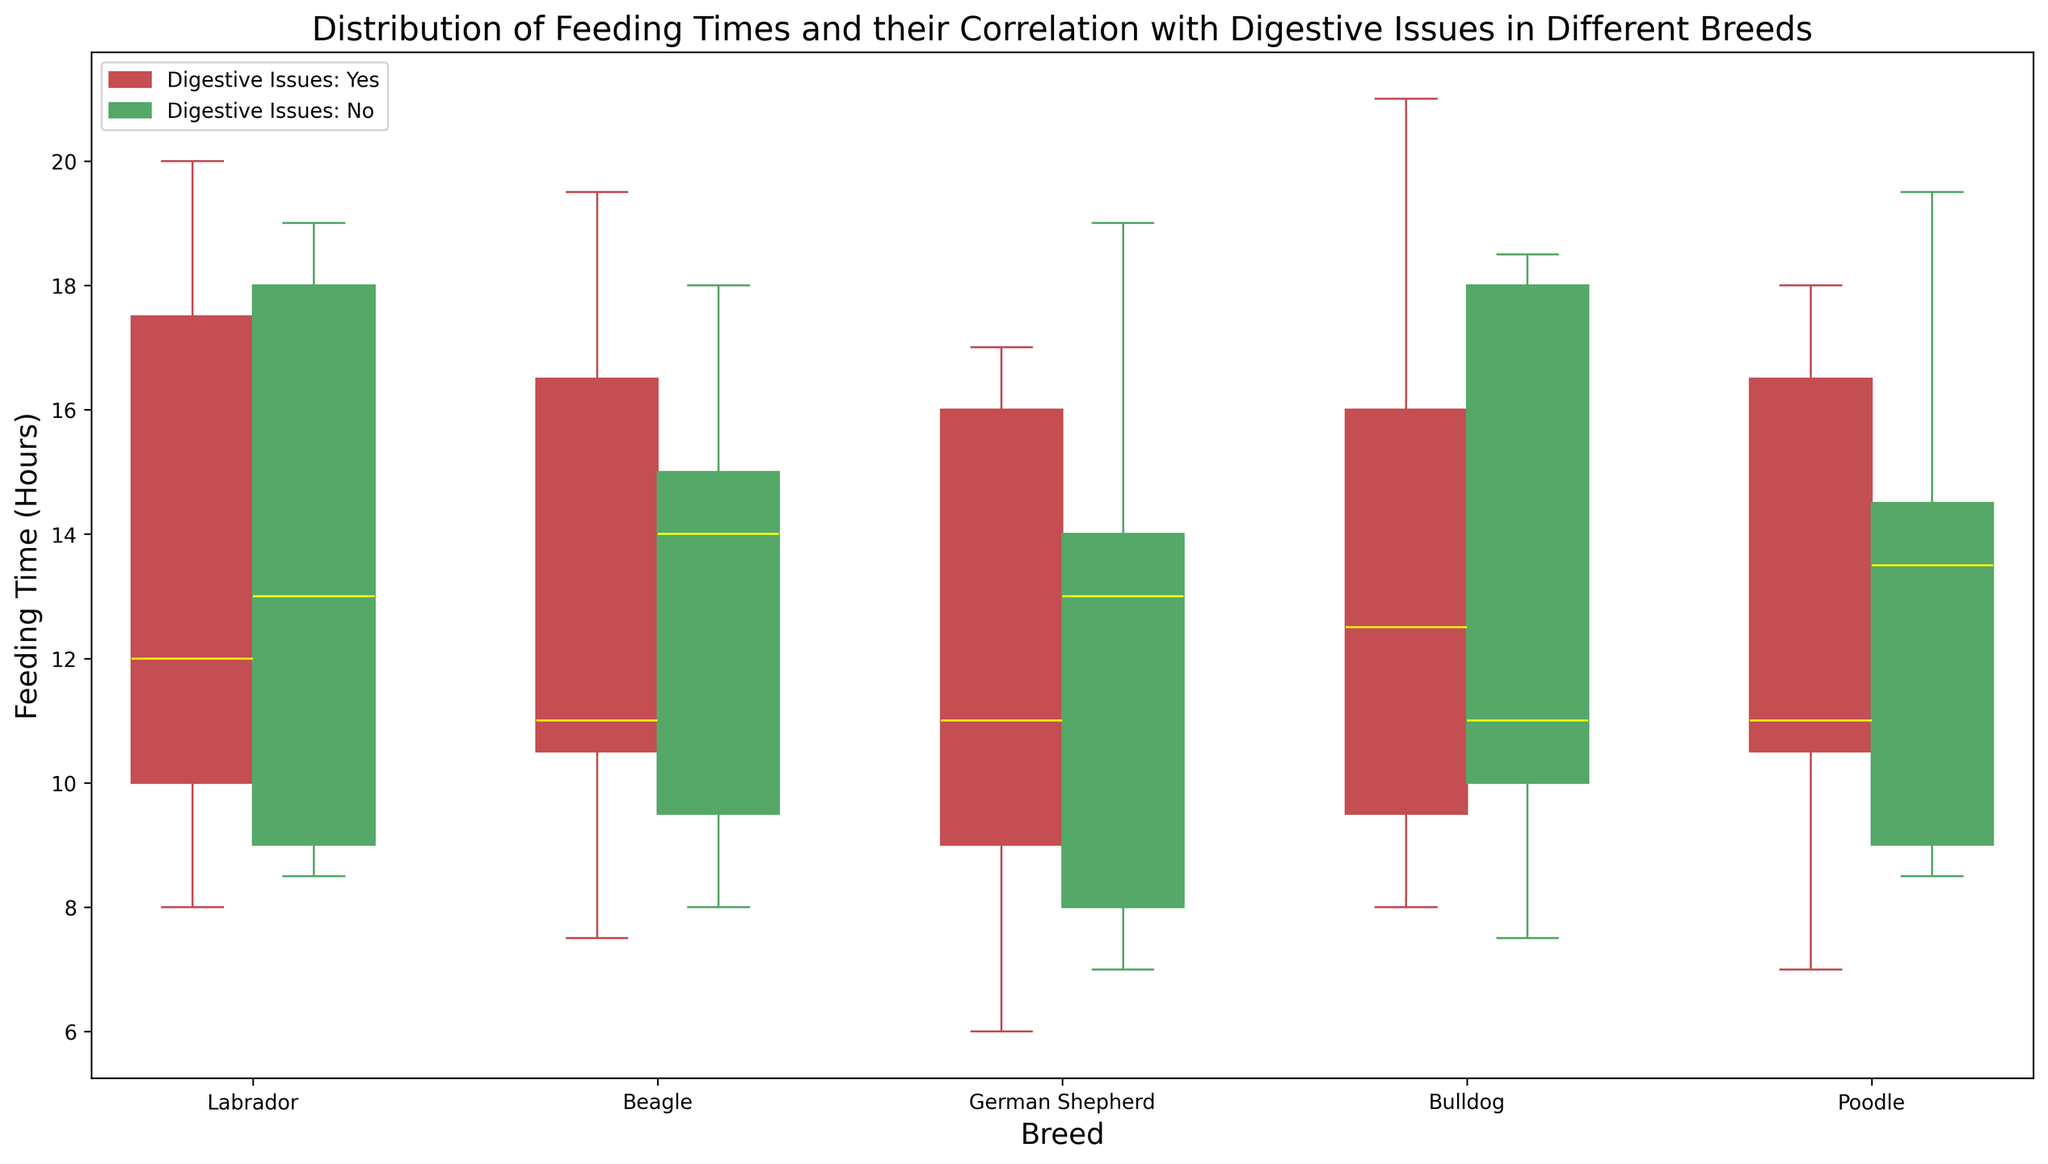What's the median feeding time for Labradors with digestive issues? Locate the box plot for Labradors with digestive issues (red boxplot). The median is the yellow line within the box. For Labradors with digestive issues, it appears to be around 12:00 (noon).
Answer: 12:00 Which breed experiences the earliest feeding time with digestive issues? Observe the lowest whisker across all red box plots, which represents the earliest feeding time. The German Shepherd has the earliest time around 06:00.
Answer: German Shepherd Do Beagles without digestive issues feed later than Labradors without digestive issues on average? Compare the median (yellow line) of the green box plots for Beagles and Labradors. Beagles' median without issues is around 15:00, while Labradors' median is around 19:00. Thus, Beagles eat earlier on average.
Answer: No Are Bulldogs' feeding times more dispersed for those with digestive issues compared to those without? Compare the height of the red box (with issues) and the green box (without issues) for Bulldogs. The red box appears more spread out, indicating more variability.
Answer: Yes What is the range of feeding times for Poodles with digestive issues? Find the minimum and maximum whiskers of the red box plot for Poodles, which roughly range from 07:00 to 18:00. The range is from 07:00 to 18:00.
Answer: 07:00 to 18:00 Which breed has the smallest interquartile range (IQR) for feeding times without digestive issues? The IQR is the range between the bottom and top of the box. Observe the green box plots, and the breed with the shortest height is the Poodle.
Answer: Poodle Do any breeds show overlap in the feeding times of dogs with and without digestive issues? Look for overlaps in the ranges of the red and green box plots for each breed. All breeds show varying degrees of overlap in feeding times between the two groups.
Answer: Yes For which breed is the difference in median feeding times with and without digestive issues the greatest? Compare the distance between the yellow lines in the red and green box plots. The greatest difference appears to be in Beagles, where the medians are 11:00 (with issues) and 14:00 (without issues).
Answer: Beagle How does the variability in feeding times for German Shepherds with digestive issues compare to those without? Look at the height of the box and the length of whiskers for German Shepherds red box plot (with issues) and green box plot (without issues). The variability (spread of data) is higher in the red box plot.
Answer: Higher for those with digestive issues 